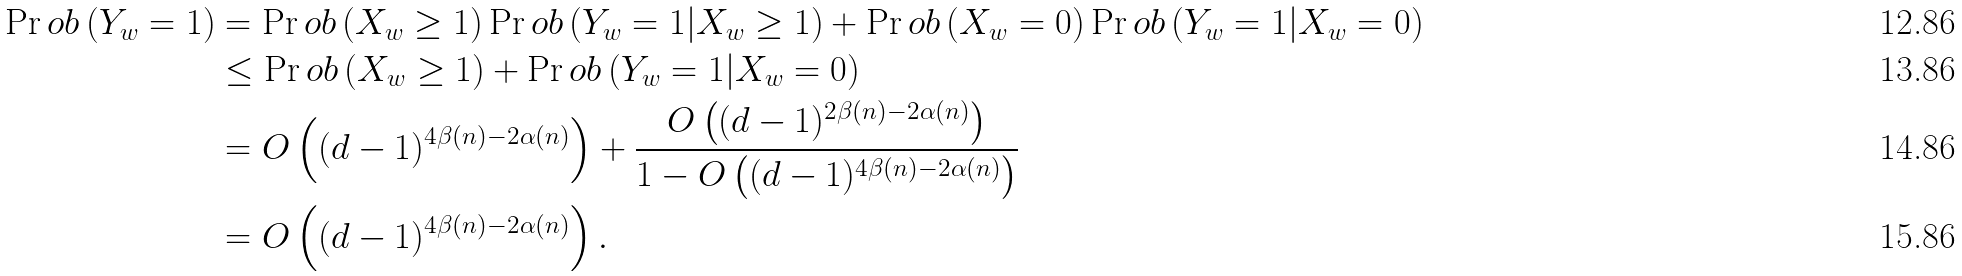<formula> <loc_0><loc_0><loc_500><loc_500>\Pr o b \left ( Y _ { w } = 1 \right ) & = \Pr o b \left ( X _ { w } \geq 1 \right ) \Pr o b \left ( Y _ { w } = 1 | X _ { w } \geq 1 \right ) + \Pr o b \left ( X _ { w } = 0 \right ) \Pr o b \left ( Y _ { w } = 1 | X _ { w } = 0 \right ) \\ & \leq \Pr o b \left ( X _ { w } \geq 1 \right ) + \Pr o b \left ( Y _ { w } = 1 | X _ { w } = 0 \right ) \\ & = O \left ( ( d - 1 ) ^ { 4 \beta ( n ) - 2 \alpha ( n ) } \right ) + \frac { O \left ( ( d - 1 ) ^ { 2 \beta ( n ) - 2 \alpha ( n ) } \right ) } { 1 - O \left ( ( d - 1 ) ^ { 4 \beta ( n ) - 2 \alpha ( n ) } \right ) } \\ & = O \left ( ( d - 1 ) ^ { 4 \beta ( n ) - 2 \alpha ( n ) } \right ) .</formula> 